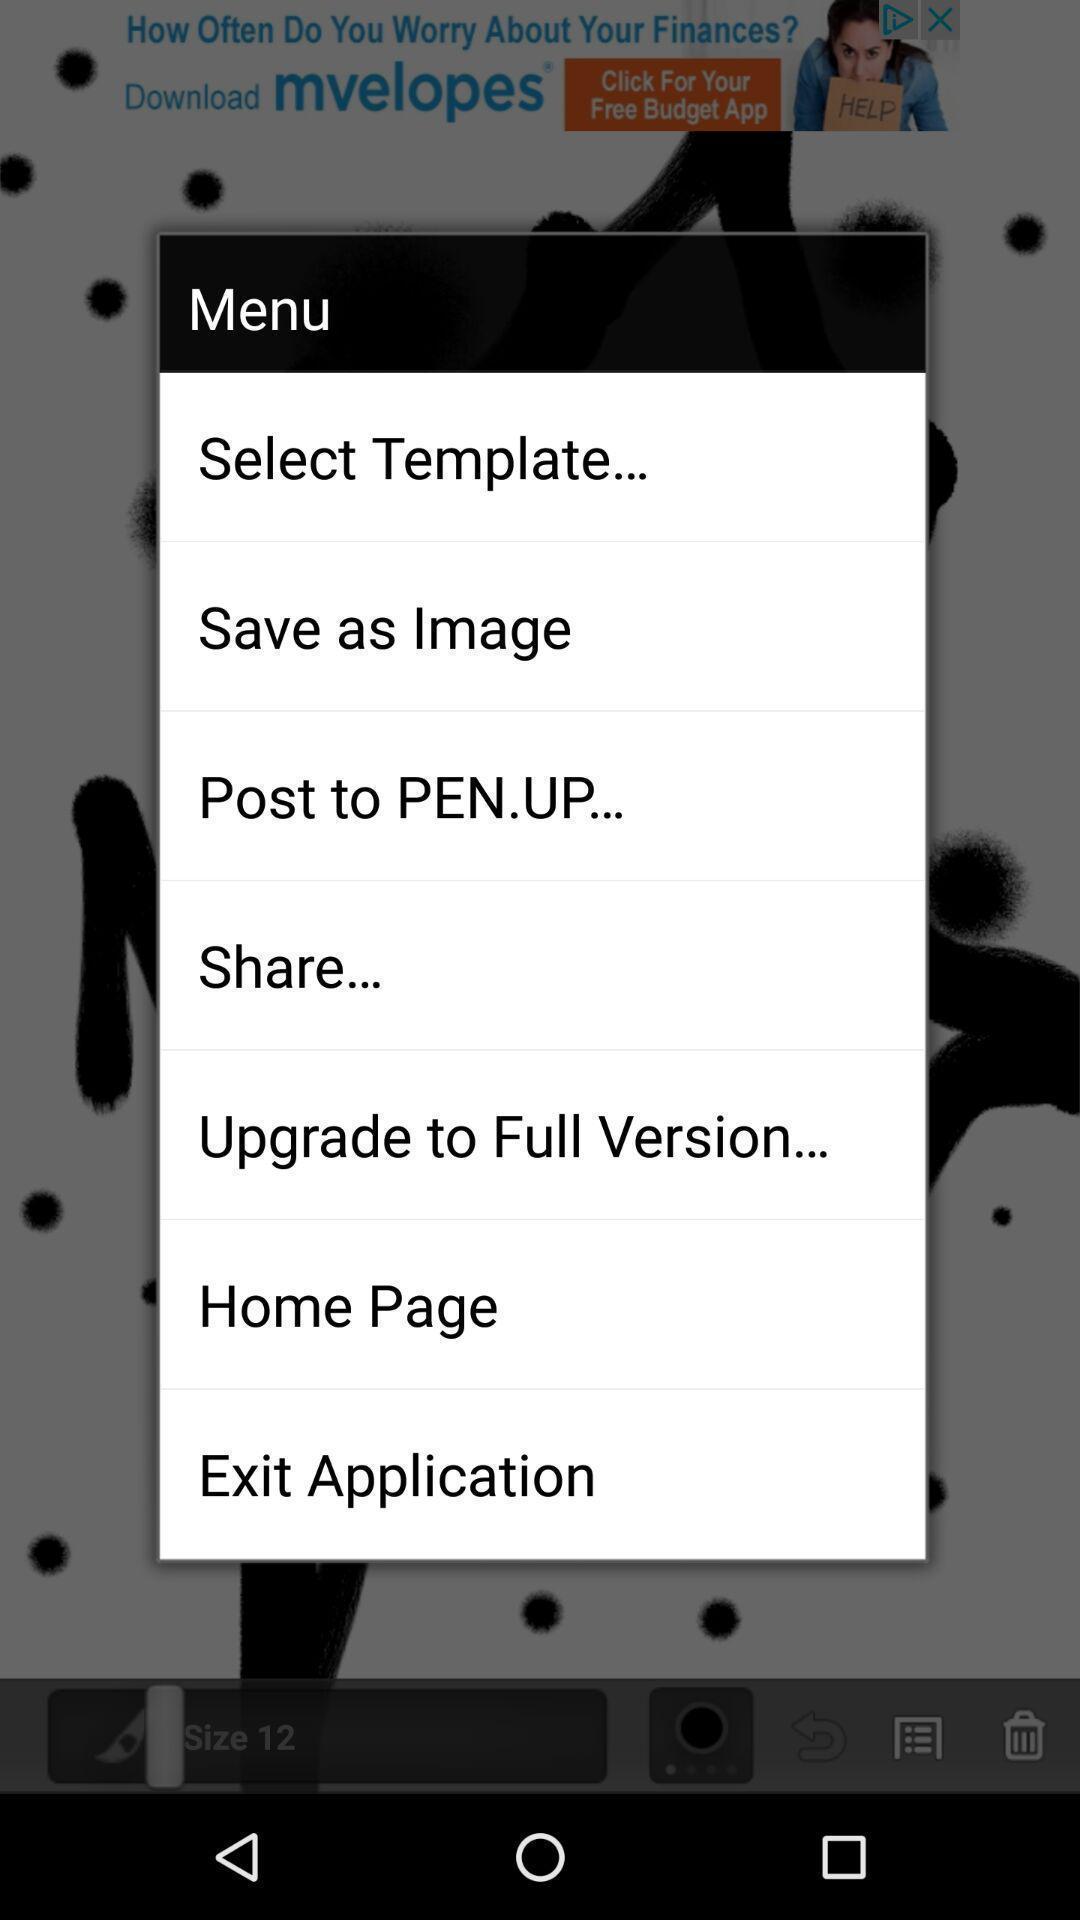Provide a description of this screenshot. Screen displaying the menu of art app. 